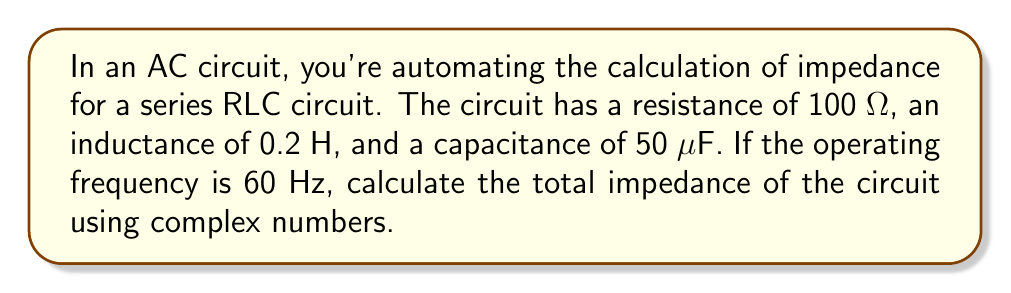Can you solve this math problem? To calculate the impedance in an AC circuit using complex numbers, we'll follow these steps:

1. Calculate the inductive reactance:
   $X_L = 2\pi fL$
   $X_L = 2\pi \cdot 60 \cdot 0.2 = 75.4$ Ω

2. Calculate the capacitive reactance:
   $X_C = \frac{1}{2\pi fC}$
   $X_C = \frac{1}{2\pi \cdot 60 \cdot 50 \times 10^{-6}} = 53.1$ Ω

3. Express the impedances in complex form:
   Resistance: $R = 100$ Ω
   Inductive reactance: $jX_L = j75.4$ Ω
   Capacitive reactance: $-jX_C = -j53.1$ Ω

4. Sum the complex impedances:
   $Z = R + j(X_L - X_C)$
   $Z = 100 + j(75.4 - 53.1)$
   $Z = 100 + j22.3$ Ω

5. Calculate the magnitude of the impedance:
   $|Z| = \sqrt{R^2 + (X_L - X_C)^2}$
   $|Z| = \sqrt{100^2 + 22.3^2} = 102.5$ Ω

6. Calculate the phase angle:
   $\theta = \tan^{-1}\left(\frac{X_L - X_C}{R}\right)$
   $\theta = \tan^{-1}\left(\frac{22.3}{100}\right) = 12.6°$

The total impedance in polar form is:
$Z = 102.5 \angle 12.6°$ Ω
Answer: $Z = 100 + j22.3$ Ω or $102.5 \angle 12.6°$ Ω 